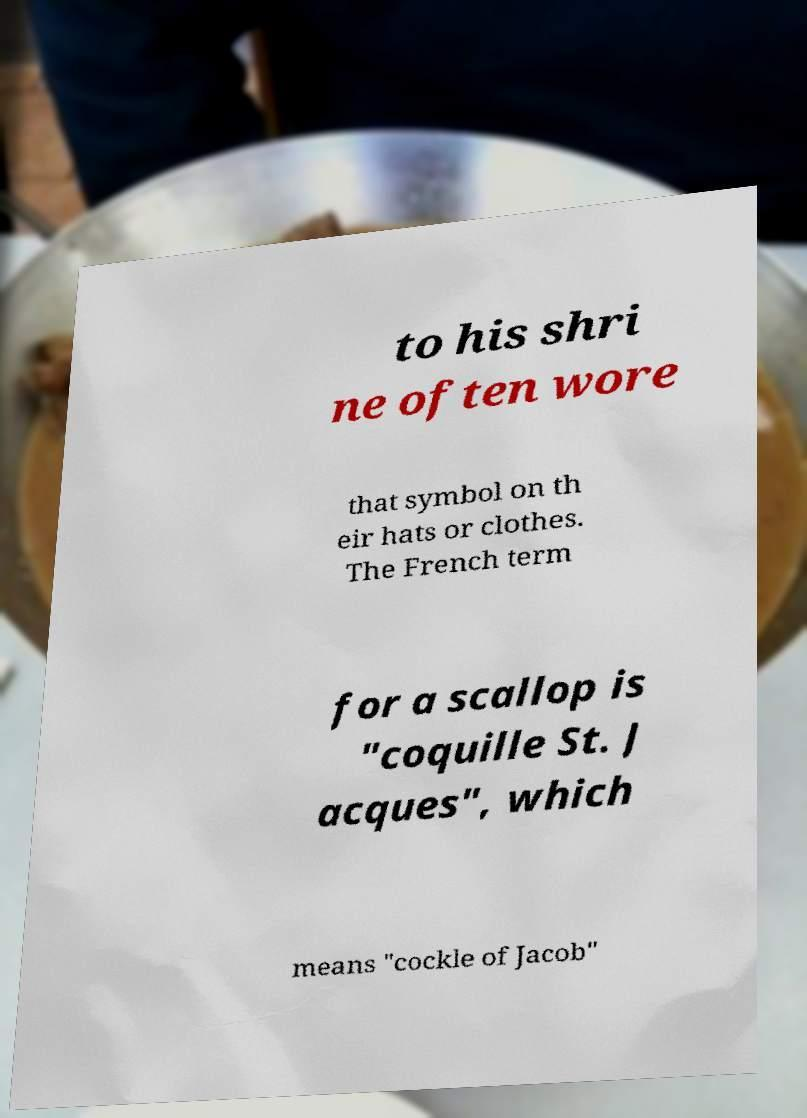Can you read and provide the text displayed in the image?This photo seems to have some interesting text. Can you extract and type it out for me? to his shri ne often wore that symbol on th eir hats or clothes. The French term for a scallop is "coquille St. J acques", which means "cockle of Jacob" 